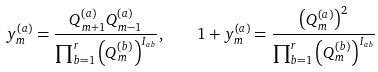<formula> <loc_0><loc_0><loc_500><loc_500>y ^ { ( a ) } _ { m } = \frac { Q ^ { ( a ) } _ { m + 1 } Q ^ { ( a ) } _ { m - 1 } } { \prod _ { b = 1 } ^ { r } \left ( Q ^ { ( b ) } _ { m } \right ) ^ { I _ { a b } } } , \quad 1 + y ^ { ( a ) } _ { m } = \frac { \left ( Q ^ { ( a ) } _ { m } \right ) ^ { 2 } } { \prod _ { b = 1 } ^ { r } \left ( Q ^ { ( b ) } _ { m } \right ) ^ { I _ { a b } } }</formula> 